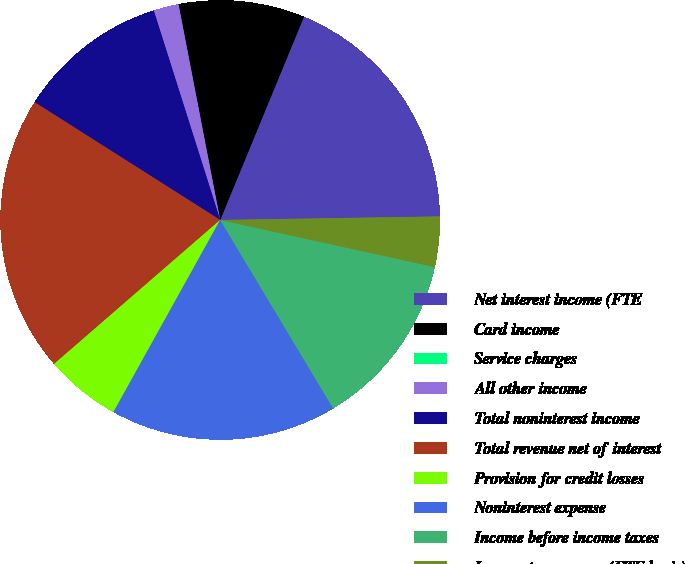Convert chart to OTSL. <chart><loc_0><loc_0><loc_500><loc_500><pie_chart><fcel>Net interest income (FTE<fcel>Card income<fcel>Service charges<fcel>All other income<fcel>Total noninterest income<fcel>Total revenue net of interest<fcel>Provision for credit losses<fcel>Noninterest expense<fcel>Income before income taxes<fcel>Income tax expense (FTE basis)<nl><fcel>18.52%<fcel>9.26%<fcel>0.0%<fcel>1.85%<fcel>11.11%<fcel>20.37%<fcel>5.56%<fcel>16.67%<fcel>12.96%<fcel>3.7%<nl></chart> 